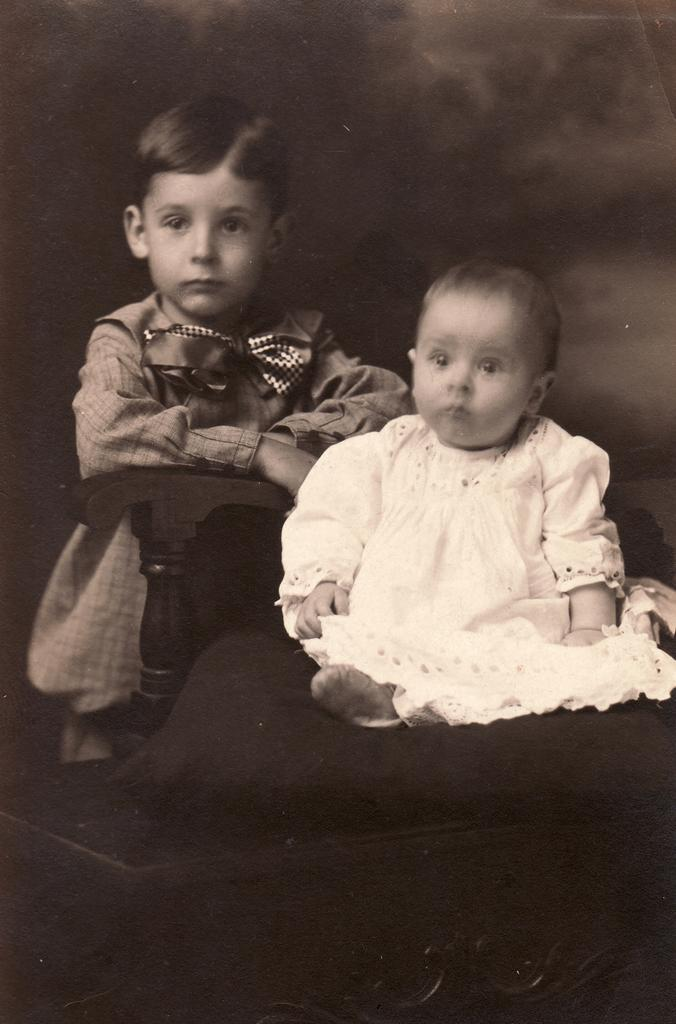How many children are present in the image? There are two kids in the image. What object can be seen in the image that might be used for sitting? There is a chair in the image. What type of glove is being used by one of the kids in the image? There is no glove present in the image; only two kids and a chair are visible. 